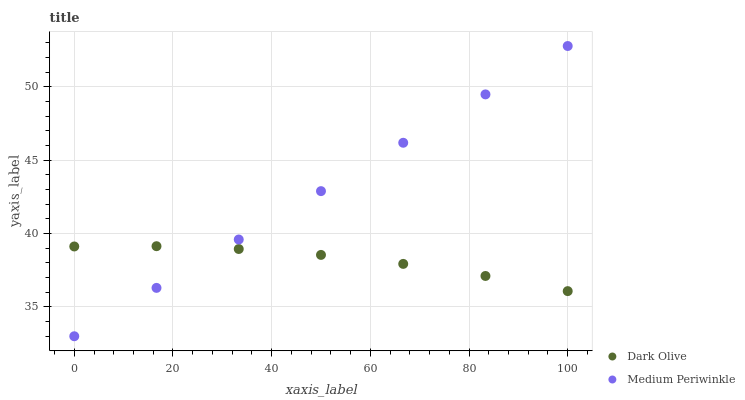Does Dark Olive have the minimum area under the curve?
Answer yes or no. Yes. Does Medium Periwinkle have the maximum area under the curve?
Answer yes or no. Yes. Does Medium Periwinkle have the minimum area under the curve?
Answer yes or no. No. Is Medium Periwinkle the smoothest?
Answer yes or no. Yes. Is Dark Olive the roughest?
Answer yes or no. Yes. Is Medium Periwinkle the roughest?
Answer yes or no. No. Does Medium Periwinkle have the lowest value?
Answer yes or no. Yes. Does Medium Periwinkle have the highest value?
Answer yes or no. Yes. Does Dark Olive intersect Medium Periwinkle?
Answer yes or no. Yes. Is Dark Olive less than Medium Periwinkle?
Answer yes or no. No. Is Dark Olive greater than Medium Periwinkle?
Answer yes or no. No. 